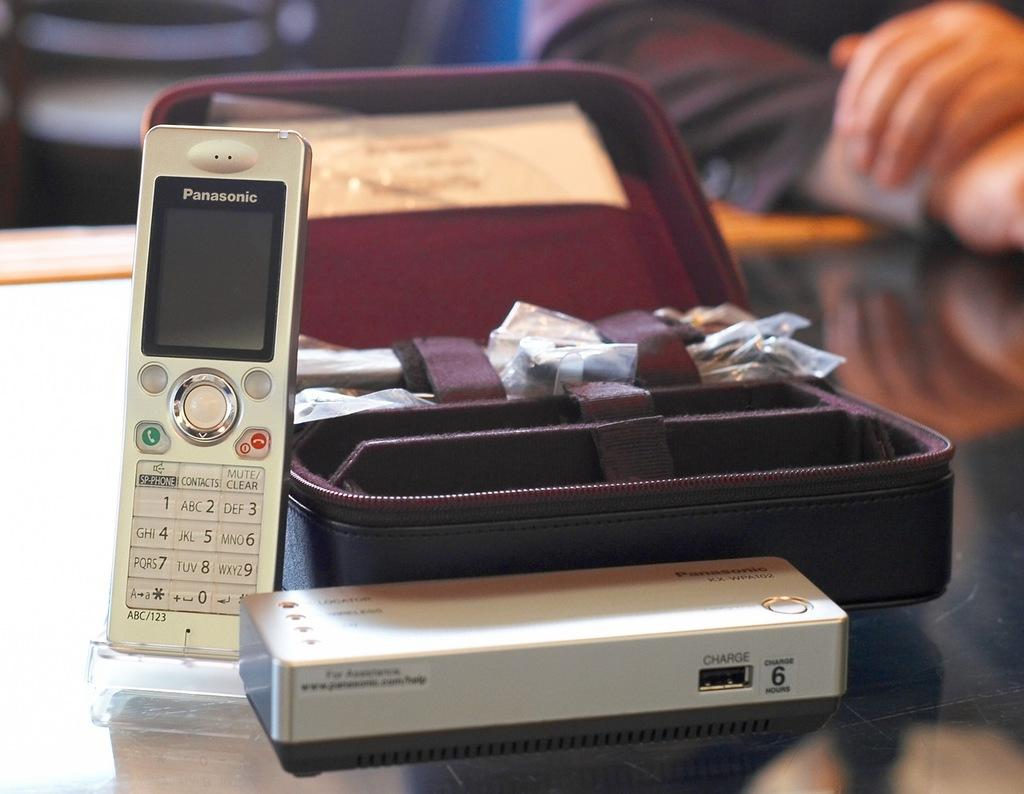What objects are in the foreground of the image? There is a remote, a box, and a suitcase in the foreground of the image. What might the suitcase suggest about the scene? The presence of a suitcase might suggest that someone is preparing to travel or has recently returned from a trip. Can you describe the people in the background of the image? There are two persons in the background of the image. What can be inferred about the time of day the image was taken? The image was likely taken during the day, as there is sufficient lighting to see the objects and people clearly. What type of love is being expressed between the family members in the image? There is no family present in the image, and therefore no love can be expressed between family members. 